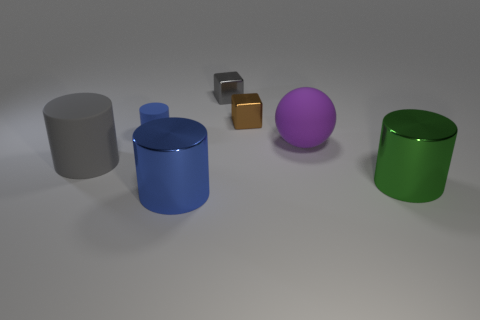What is the shape of the metal thing that is behind the green thing and in front of the gray block?
Offer a very short reply. Cube. What number of big metallic cylinders have the same color as the tiny matte cylinder?
Give a very brief answer. 1. There is a big metal thing that is on the left side of the rubber ball; is its color the same as the small cylinder?
Your response must be concise. Yes. Is there a cyan cylinder?
Your answer should be compact. No. How many other objects are there of the same size as the blue matte thing?
Offer a very short reply. 2. There is a block on the right side of the small gray metal block; is it the same color as the matte object that is to the left of the small blue matte thing?
Provide a short and direct response. No. What size is the other metal thing that is the same shape as the green metal object?
Keep it short and to the point. Large. Does the cylinder that is to the right of the blue shiny cylinder have the same material as the large purple thing in front of the gray block?
Ensure brevity in your answer.  No. What number of shiny things are either gray cylinders or small cyan things?
Your answer should be very brief. 0. What material is the large object that is to the left of the matte cylinder that is behind the gray thing in front of the tiny blue matte cylinder made of?
Keep it short and to the point. Rubber. 